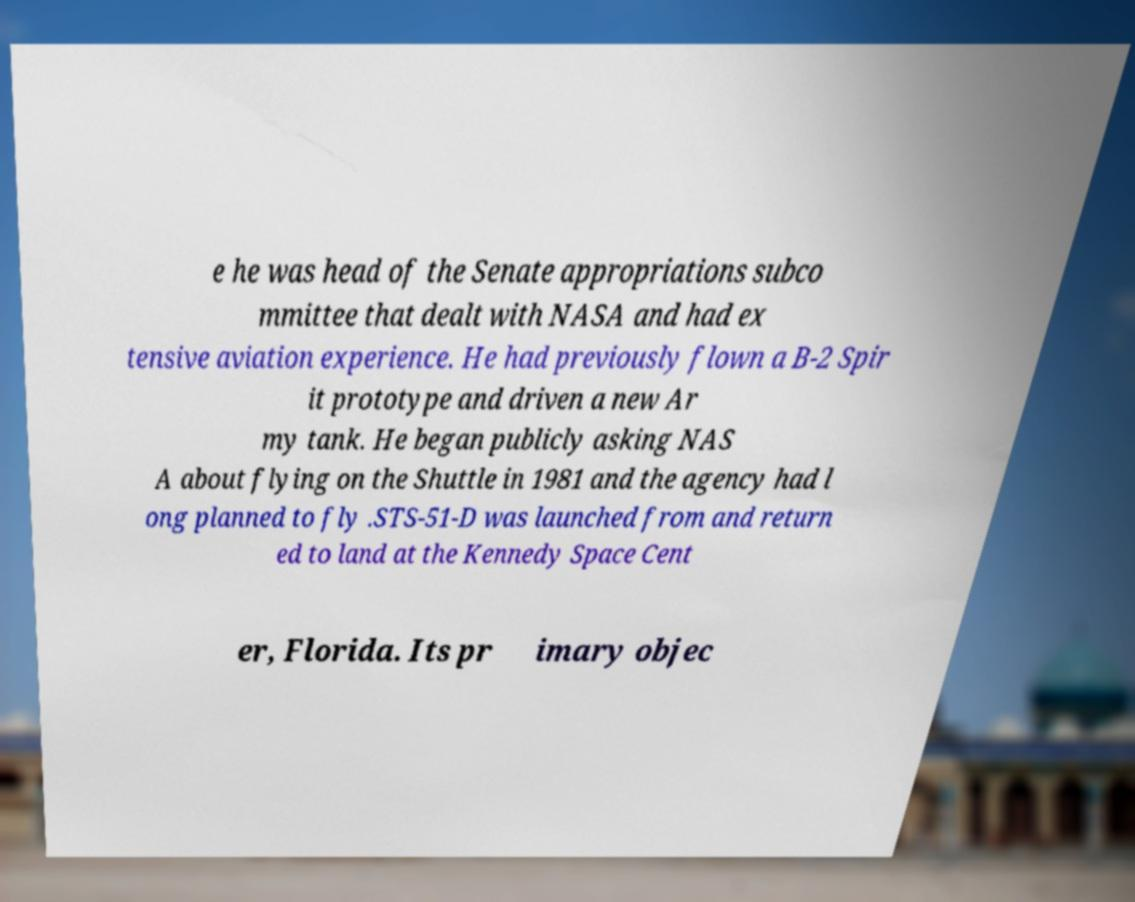Can you read and provide the text displayed in the image?This photo seems to have some interesting text. Can you extract and type it out for me? e he was head of the Senate appropriations subco mmittee that dealt with NASA and had ex tensive aviation experience. He had previously flown a B-2 Spir it prototype and driven a new Ar my tank. He began publicly asking NAS A about flying on the Shuttle in 1981 and the agency had l ong planned to fly .STS-51-D was launched from and return ed to land at the Kennedy Space Cent er, Florida. Its pr imary objec 